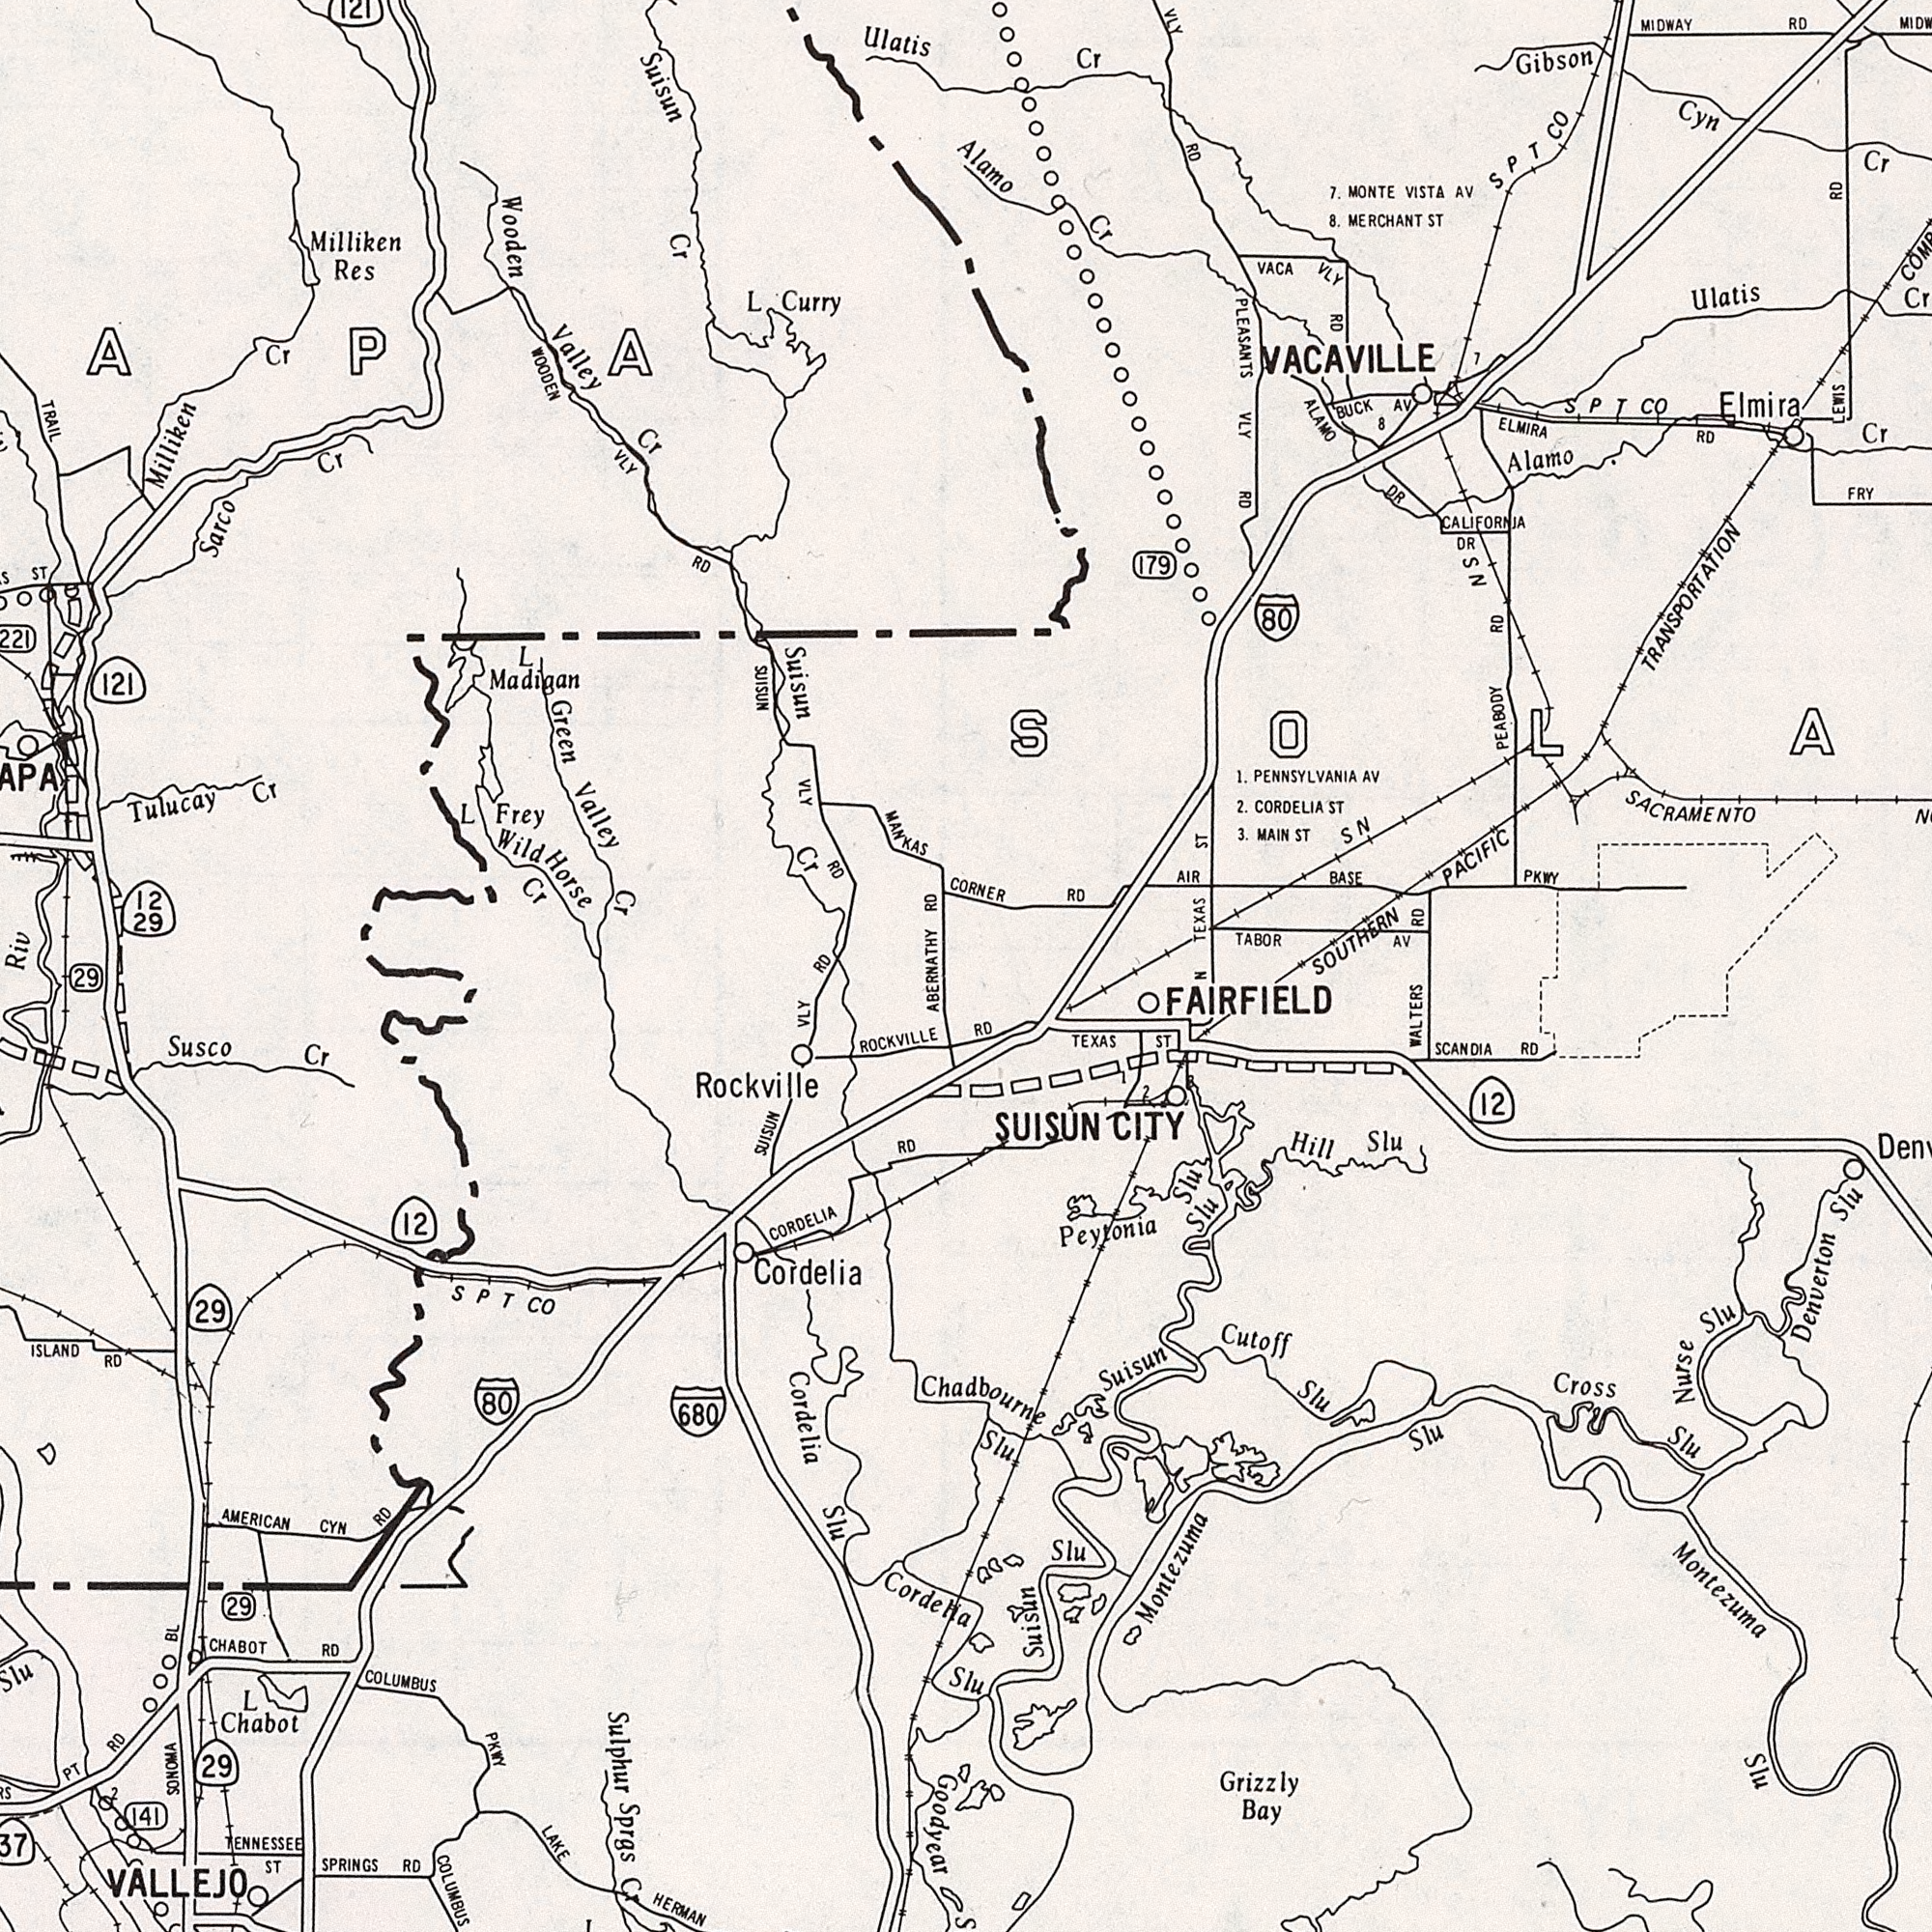What text is shown in the top-left quadrant? Wooden Valley Cr Suisun Cr Milliken Res Suisun TRAIL Wild Horse Cr Sarco Cr MANKAS Green Valley Cr Tulucay Cr Ulatis L Madigan L Frey WOODEN VLY RD RD L Curry 121 VLY RD ST 12 29 Milliken Cr 121 SUISUN Riv Cr RD ###APA What text is shown in the bottom-left quadrant? ABERNATHY ROCKVILLE Cordelia Slu Sulphur Sprgs Cr COLUMBUS Rockville Cordelia Susco Cr ISLAND RD SPRINGS RD AMERICAN CYN RD LAKE HERMAN CORDELIA RD Goodyear L Chabot SONOMA VALLEJO COLUMBUS PKWY 29 29 680 PT RD TENNESSEE ST 12 SUISUN VLY 80 29 CHABOT RD 141 SPT CO 29 BL Cordelia 2 What text is shown in the top-right quadrant? RD CORNER Cr VACAVILLE PLEASANTS VLY RD 1. PENNSYLVANIA AV OUTHERN PACIFIC TRANSPORTATION TABOR AV Alamo AIR BASE PKWY TEXAS ST 8. MERCHANT ST Gibson 7. MONTE VISTA AV Elmira ELMIRA RD VLY RD NS DR Ulatis Cr Cyn Cr Cr ALAMO DR VACA VLY RD 2. CORDELIA ST MIDWAY RD SN LEWIS RD Alamo Cr BUCK AV 3. MAIN ST FRY PEABOOY RD 80 SPT CO. 179 SACRAMENTO SPT CO CALIFORNIA 8 RD 7 What text is shown in the bottom-right quadrant? N WALTERS RD Slu Montezuma Slu Denverton Slu Montezuma Slu Nurse Slu Grizzly Bay SUISUN CITY FAIRFIELD SCANDIA RD Peytonia Slu Cross Slu Suisun Slu TEXAS ST Hill Slu Cutoff Slu Chadbourne Slu Suisun Slu 12 2 